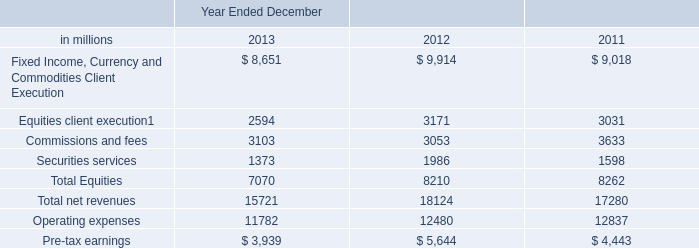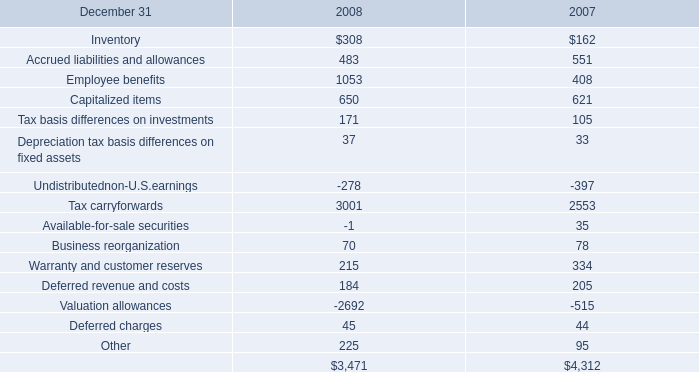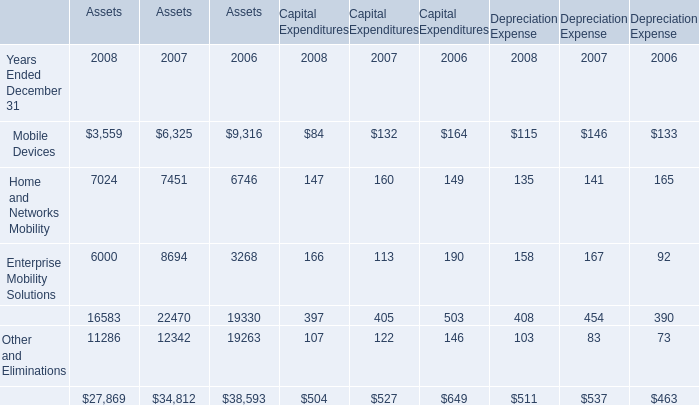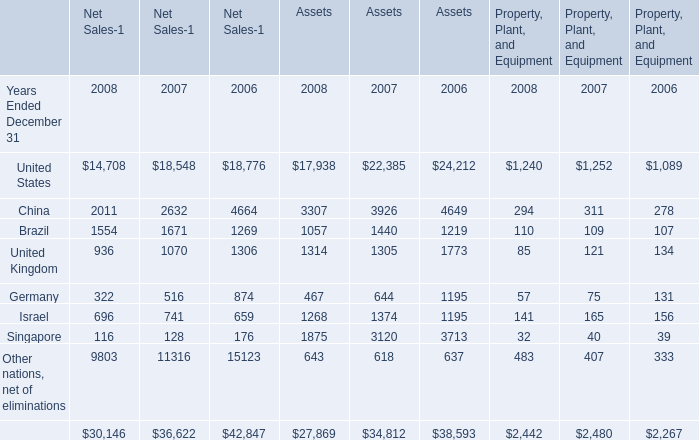What is the total amount of Mobile Devices of Assets, and Operating expenses of Year Ended December 2013 ? 
Computations: (3559.0 + 11782.0)
Answer: 15341.0. 